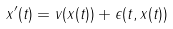<formula> <loc_0><loc_0><loc_500><loc_500>x ^ { \prime } ( t ) = v ( x ( t ) ) + \epsilon ( t , x ( t ) )</formula> 